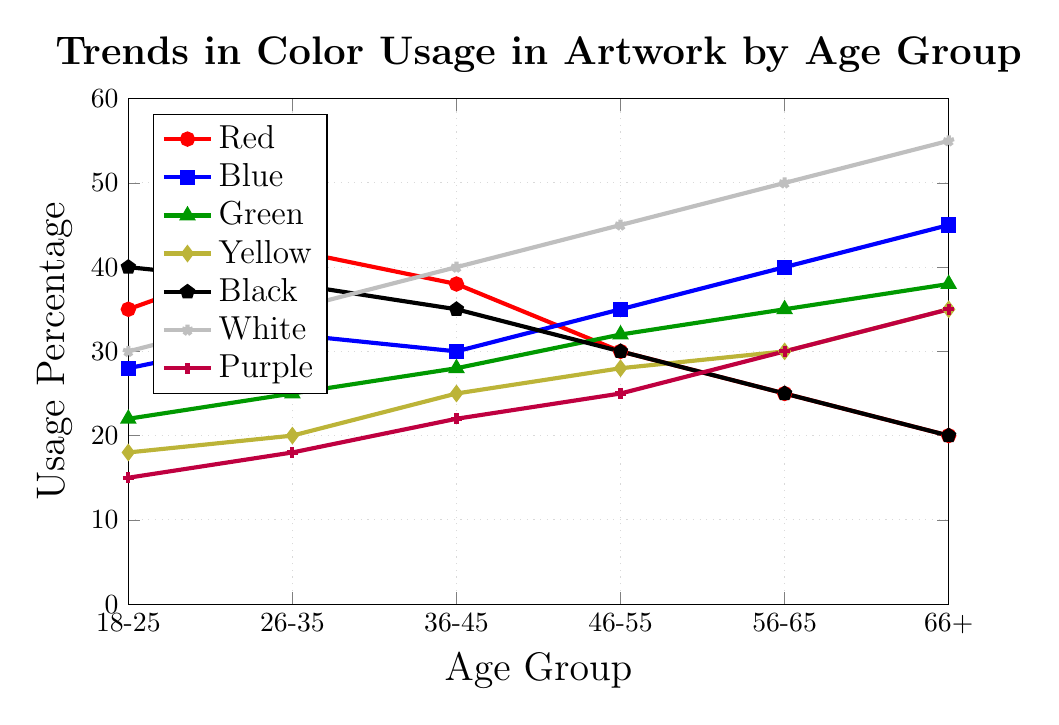Which age group has the highest usage percentage for the color red? Observing the red line in the chart, the highest point corresponds to the 26-35 age group.
Answer: 26-35 Which two age groups have equal usage percentages for the color black? Observing the black line, both the 18-25 and 66+ age groups have a usage percentage of 40.
Answer: 18-25 and 66+ Between the age groups 36-45 and 46-55, which one shows a higher usage of the color green? Observing the green line, the point for the age group 46-55 is higher than that for 36-45.
Answer: 46-55 What is the difference in the usage percentages of the color blue between age groups 56-65 and 18-25? The blue line has a usage percentage of 40 for 56-65 and 28 for 18-25. The difference is 40 - 28.
Answer: 12 Which color shows an increasing trend across all age groups? Observing all lines, the color white line shows a consistent upward trend across all age groups.
Answer: White What is the sum of the usage percentages of the color yellow for age groups 26-35 and 36-45? The yellow line shows 20 for 26-35 and 25 for 36-45. Their sum is 20 + 25.
Answer: 45 Which age group uses the color purple the least? The purple line has its lowest point at the 18-25 age group.
Answer: 18-25 How many age groups have higher usage percentages for the color red compared to blue? By comparing the red and blue lines, the age groups 18-25, 26-35, and 36-45 show higher percentages for red than blue.
Answer: 3 What is the average usage percentage of the color white across all age groups? The white line shows percentages 30, 35, 40, 45, 50, and 55 for the respective age groups. The sum is 30 + 35 + 40 + 45 + 50 + 55 = 255. The average is 255 / 6.
Answer: 42.5 Is there any age group where usage percentages of green and purple are the same? Observing the green and purple lines, they never intersect at the same percentages for any age group.
Answer: No 